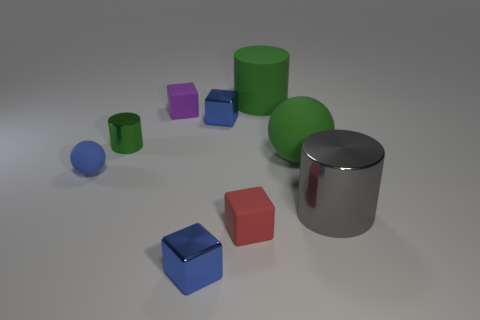There is a tiny blue metal thing that is in front of the sphere that is right of the tiny purple rubber thing; is there a thing that is left of it?
Ensure brevity in your answer.  Yes. What material is the big gray cylinder?
Your answer should be compact. Metal. How many other objects are there of the same shape as the red object?
Your answer should be very brief. 3. Does the large gray object have the same shape as the blue rubber thing?
Ensure brevity in your answer.  No. What number of things are either small objects in front of the blue matte sphere or metallic cylinders that are to the right of the big sphere?
Your answer should be compact. 3. What number of objects are big purple metal cylinders or big gray cylinders?
Give a very brief answer. 1. How many big green rubber objects are left of the green matte thing in front of the matte cylinder?
Make the answer very short. 1. What number of other objects are there of the same size as the green metallic object?
Keep it short and to the point. 5. There is a ball that is the same color as the small shiny cylinder; what size is it?
Your answer should be very brief. Large. Does the big green matte thing that is right of the big matte cylinder have the same shape as the tiny purple object?
Provide a short and direct response. No. 